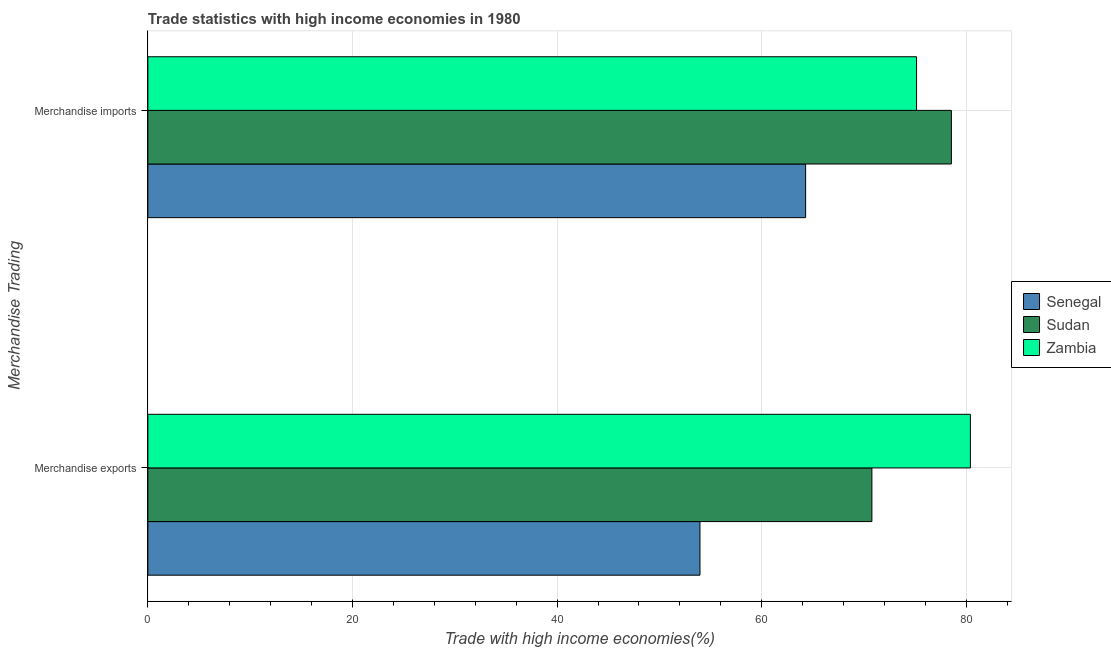Are the number of bars per tick equal to the number of legend labels?
Give a very brief answer. Yes. How many bars are there on the 1st tick from the top?
Your answer should be very brief. 3. How many bars are there on the 1st tick from the bottom?
Provide a short and direct response. 3. What is the merchandise exports in Zambia?
Offer a terse response. 80.39. Across all countries, what is the maximum merchandise imports?
Your answer should be very brief. 78.53. Across all countries, what is the minimum merchandise exports?
Your answer should be very brief. 53.96. In which country was the merchandise exports maximum?
Offer a very short reply. Zambia. In which country was the merchandise exports minimum?
Ensure brevity in your answer.  Senegal. What is the total merchandise exports in the graph?
Provide a succinct answer. 205.12. What is the difference between the merchandise imports in Sudan and that in Zambia?
Your answer should be compact. 3.41. What is the difference between the merchandise imports in Sudan and the merchandise exports in Zambia?
Your response must be concise. -1.86. What is the average merchandise imports per country?
Offer a very short reply. 72.65. What is the difference between the merchandise imports and merchandise exports in Zambia?
Give a very brief answer. -5.26. What is the ratio of the merchandise exports in Sudan to that in Zambia?
Provide a short and direct response. 0.88. Is the merchandise exports in Zambia less than that in Sudan?
Make the answer very short. No. What does the 1st bar from the top in Merchandise imports represents?
Provide a succinct answer. Zambia. What does the 2nd bar from the bottom in Merchandise exports represents?
Ensure brevity in your answer.  Sudan. Are all the bars in the graph horizontal?
Offer a very short reply. Yes. How many countries are there in the graph?
Make the answer very short. 3. Does the graph contain grids?
Offer a very short reply. Yes. Where does the legend appear in the graph?
Your response must be concise. Center right. What is the title of the graph?
Give a very brief answer. Trade statistics with high income economies in 1980. Does "Liberia" appear as one of the legend labels in the graph?
Offer a terse response. No. What is the label or title of the X-axis?
Make the answer very short. Trade with high income economies(%). What is the label or title of the Y-axis?
Ensure brevity in your answer.  Merchandise Trading. What is the Trade with high income economies(%) in Senegal in Merchandise exports?
Offer a very short reply. 53.96. What is the Trade with high income economies(%) in Sudan in Merchandise exports?
Provide a succinct answer. 70.76. What is the Trade with high income economies(%) in Zambia in Merchandise exports?
Offer a very short reply. 80.39. What is the Trade with high income economies(%) of Senegal in Merchandise imports?
Give a very brief answer. 64.29. What is the Trade with high income economies(%) of Sudan in Merchandise imports?
Your answer should be very brief. 78.53. What is the Trade with high income economies(%) of Zambia in Merchandise imports?
Provide a succinct answer. 75.13. Across all Merchandise Trading, what is the maximum Trade with high income economies(%) of Senegal?
Make the answer very short. 64.29. Across all Merchandise Trading, what is the maximum Trade with high income economies(%) of Sudan?
Keep it short and to the point. 78.53. Across all Merchandise Trading, what is the maximum Trade with high income economies(%) in Zambia?
Provide a succinct answer. 80.39. Across all Merchandise Trading, what is the minimum Trade with high income economies(%) of Senegal?
Make the answer very short. 53.96. Across all Merchandise Trading, what is the minimum Trade with high income economies(%) in Sudan?
Offer a very short reply. 70.76. Across all Merchandise Trading, what is the minimum Trade with high income economies(%) in Zambia?
Your answer should be compact. 75.13. What is the total Trade with high income economies(%) of Senegal in the graph?
Keep it short and to the point. 118.25. What is the total Trade with high income economies(%) in Sudan in the graph?
Give a very brief answer. 149.3. What is the total Trade with high income economies(%) of Zambia in the graph?
Offer a very short reply. 155.52. What is the difference between the Trade with high income economies(%) of Senegal in Merchandise exports and that in Merchandise imports?
Provide a succinct answer. -10.33. What is the difference between the Trade with high income economies(%) of Sudan in Merchandise exports and that in Merchandise imports?
Keep it short and to the point. -7.77. What is the difference between the Trade with high income economies(%) in Zambia in Merchandise exports and that in Merchandise imports?
Make the answer very short. 5.26. What is the difference between the Trade with high income economies(%) in Senegal in Merchandise exports and the Trade with high income economies(%) in Sudan in Merchandise imports?
Offer a terse response. -24.57. What is the difference between the Trade with high income economies(%) of Senegal in Merchandise exports and the Trade with high income economies(%) of Zambia in Merchandise imports?
Your response must be concise. -21.17. What is the difference between the Trade with high income economies(%) of Sudan in Merchandise exports and the Trade with high income economies(%) of Zambia in Merchandise imports?
Make the answer very short. -4.37. What is the average Trade with high income economies(%) in Senegal per Merchandise Trading?
Ensure brevity in your answer.  59.12. What is the average Trade with high income economies(%) of Sudan per Merchandise Trading?
Give a very brief answer. 74.65. What is the average Trade with high income economies(%) of Zambia per Merchandise Trading?
Keep it short and to the point. 77.76. What is the difference between the Trade with high income economies(%) of Senegal and Trade with high income economies(%) of Sudan in Merchandise exports?
Your answer should be very brief. -16.8. What is the difference between the Trade with high income economies(%) of Senegal and Trade with high income economies(%) of Zambia in Merchandise exports?
Offer a very short reply. -26.43. What is the difference between the Trade with high income economies(%) of Sudan and Trade with high income economies(%) of Zambia in Merchandise exports?
Keep it short and to the point. -9.63. What is the difference between the Trade with high income economies(%) in Senegal and Trade with high income economies(%) in Sudan in Merchandise imports?
Keep it short and to the point. -14.25. What is the difference between the Trade with high income economies(%) in Senegal and Trade with high income economies(%) in Zambia in Merchandise imports?
Keep it short and to the point. -10.84. What is the difference between the Trade with high income economies(%) of Sudan and Trade with high income economies(%) of Zambia in Merchandise imports?
Your answer should be very brief. 3.41. What is the ratio of the Trade with high income economies(%) in Senegal in Merchandise exports to that in Merchandise imports?
Your answer should be compact. 0.84. What is the ratio of the Trade with high income economies(%) of Sudan in Merchandise exports to that in Merchandise imports?
Your response must be concise. 0.9. What is the ratio of the Trade with high income economies(%) in Zambia in Merchandise exports to that in Merchandise imports?
Your answer should be compact. 1.07. What is the difference between the highest and the second highest Trade with high income economies(%) in Senegal?
Offer a terse response. 10.33. What is the difference between the highest and the second highest Trade with high income economies(%) in Sudan?
Provide a succinct answer. 7.77. What is the difference between the highest and the second highest Trade with high income economies(%) in Zambia?
Provide a short and direct response. 5.26. What is the difference between the highest and the lowest Trade with high income economies(%) of Senegal?
Provide a short and direct response. 10.33. What is the difference between the highest and the lowest Trade with high income economies(%) of Sudan?
Ensure brevity in your answer.  7.77. What is the difference between the highest and the lowest Trade with high income economies(%) of Zambia?
Offer a terse response. 5.26. 